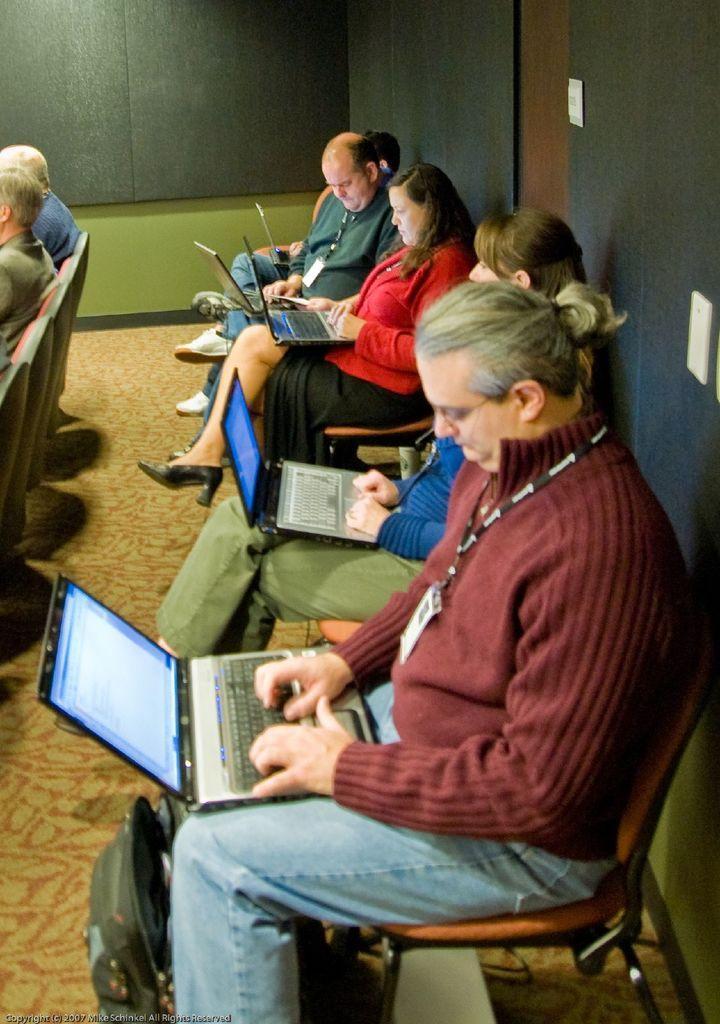Can you describe this image briefly? In the image we can see there are many people wearing clothes and some of them are wearing identity cards, and the people are sitting on the chair. There are laptops, this is a bag, carpet and a wall. This is a watermark. 